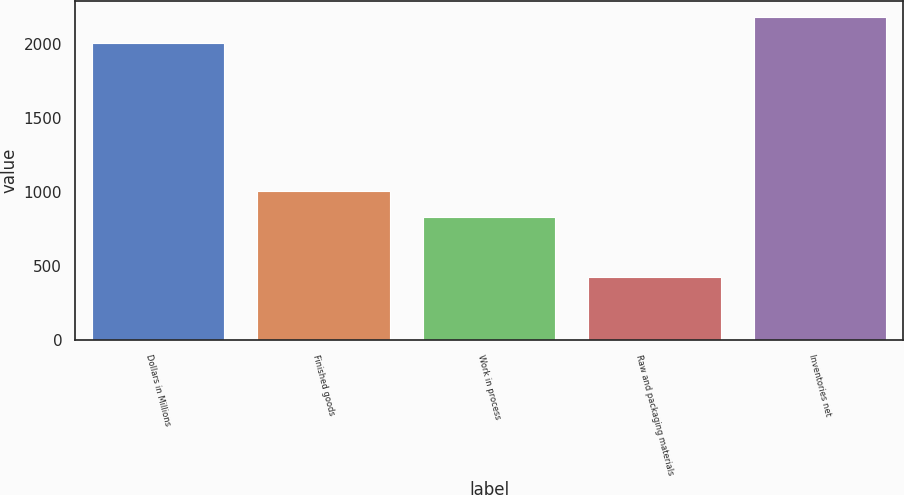Convert chart. <chart><loc_0><loc_0><loc_500><loc_500><bar_chart><fcel>Dollars in Millions<fcel>Finished goods<fcel>Work in process<fcel>Raw and packaging materials<fcel>Inventories net<nl><fcel>2007<fcel>1007.8<fcel>834<fcel>424<fcel>2180.8<nl></chart> 